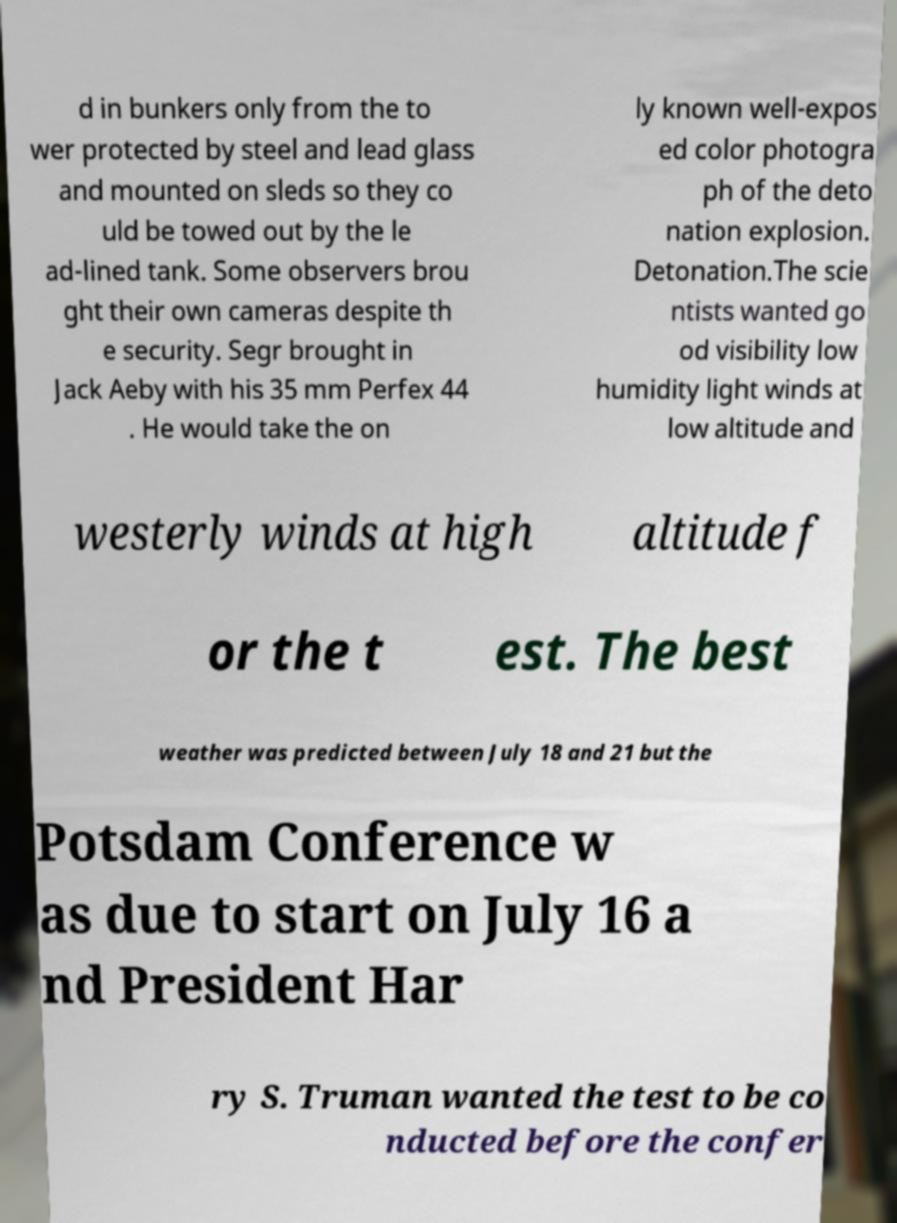Please read and relay the text visible in this image. What does it say? d in bunkers only from the to wer protected by steel and lead glass and mounted on sleds so they co uld be towed out by the le ad-lined tank. Some observers brou ght their own cameras despite th e security. Segr brought in Jack Aeby with his 35 mm Perfex 44 . He would take the on ly known well-expos ed color photogra ph of the deto nation explosion. Detonation.The scie ntists wanted go od visibility low humidity light winds at low altitude and westerly winds at high altitude f or the t est. The best weather was predicted between July 18 and 21 but the Potsdam Conference w as due to start on July 16 a nd President Har ry S. Truman wanted the test to be co nducted before the confer 